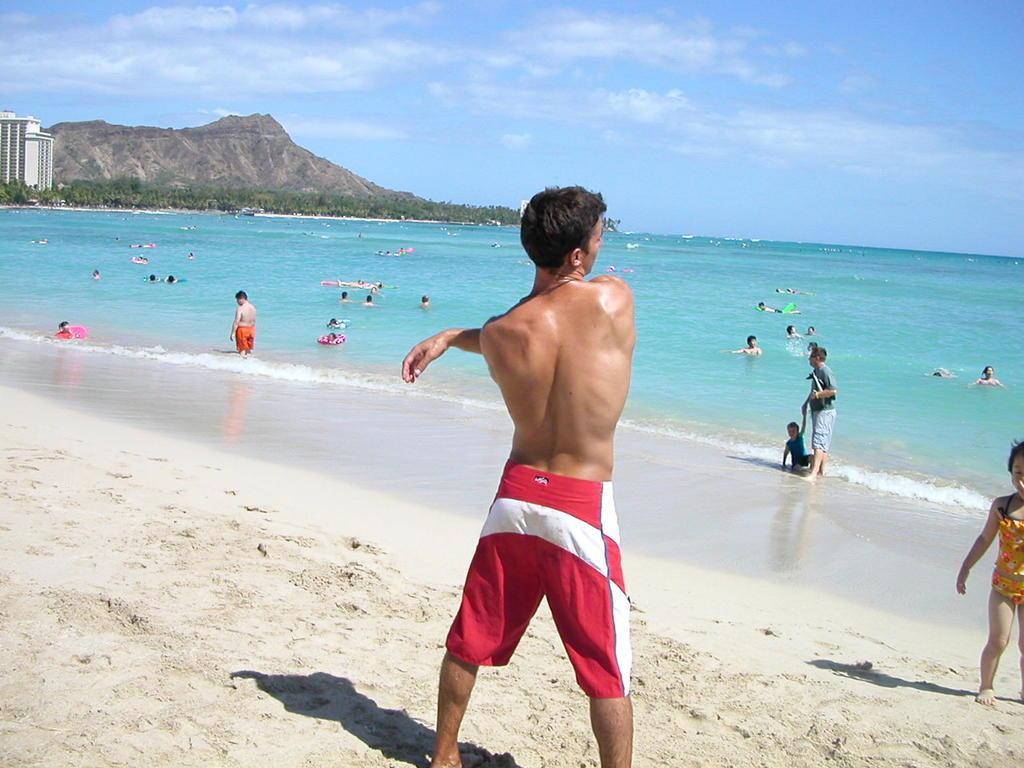Could you give a brief overview of what you see in this image? The image is taken in a beach. In the foreground of the picture there is a person and there is sand. In the center of the picture there is a water body, in the water there are many people swimming and playing. In the background towards left there are trees, mountain and buildings. At the top it is sky, sky is partially cloudy. 